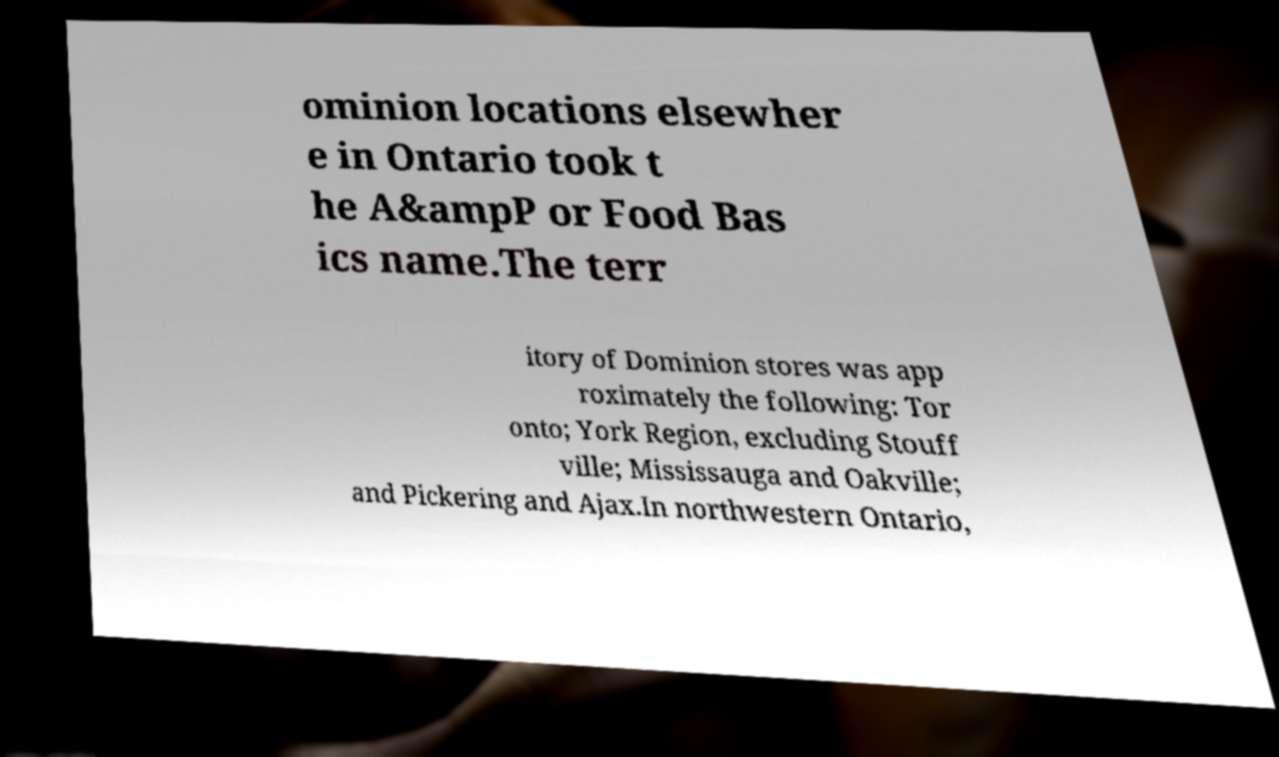Could you assist in decoding the text presented in this image and type it out clearly? ominion locations elsewher e in Ontario took t he A&ampP or Food Bas ics name.The terr itory of Dominion stores was app roximately the following: Tor onto; York Region, excluding Stouff ville; Mississauga and Oakville; and Pickering and Ajax.In northwestern Ontario, 